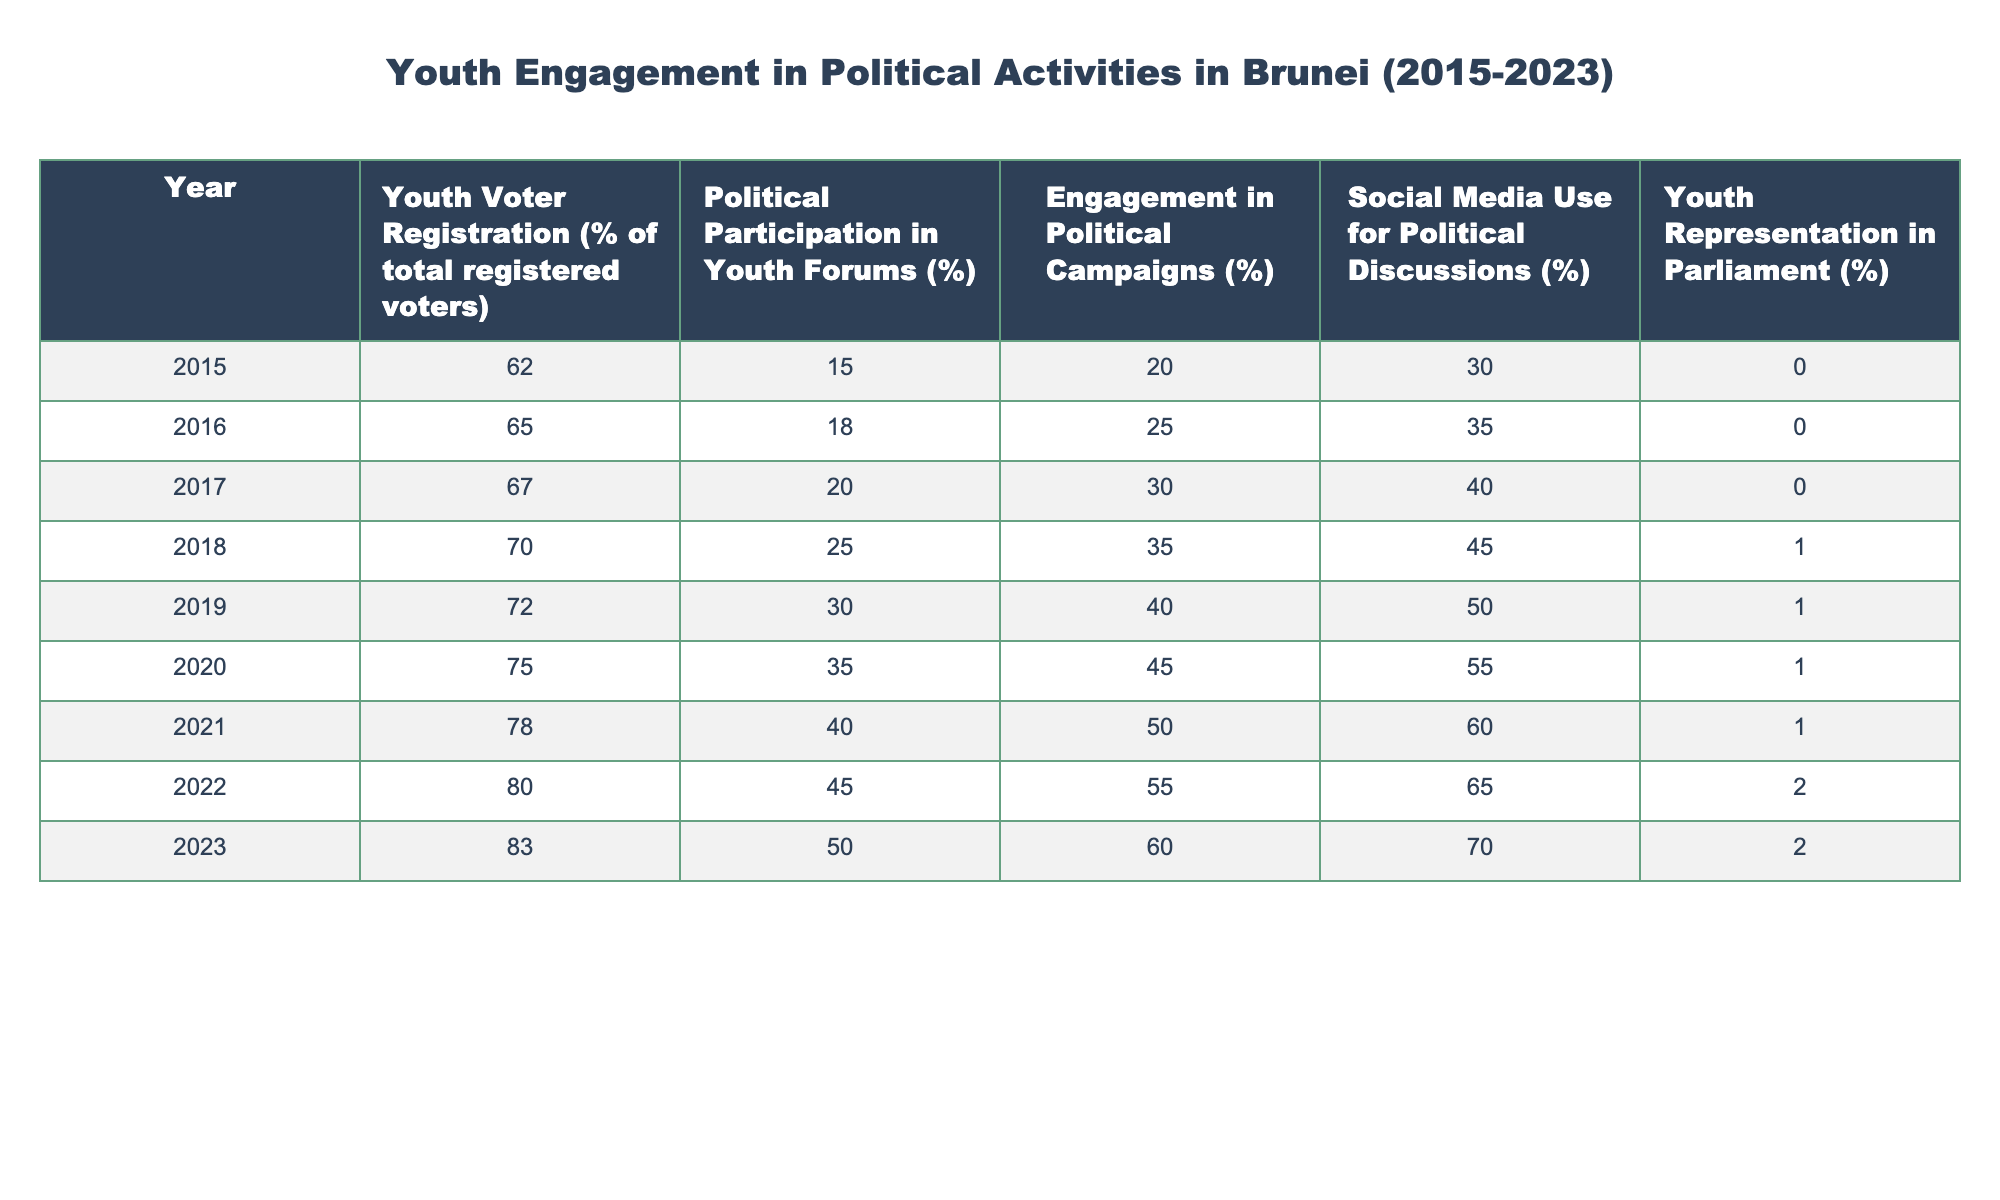What was the youth voter registration percentage in 2021? The table shows that in 2021, the youth voter registration percentage was listed as 78%.
Answer: 78% What is the highest percentage of youth engagement in political campaigns recorded within the years? By comparing the "Engagement in Political Campaigns (%)" column, 60% in 2023 is the highest recorded percentage throughout the years.
Answer: 60% Is there any year where youth representation in Parliament was above 2%? Looking at the "Youth Representation in Parliament (%)" column, the maximum value is 2% in both 2022 and 2023, indicating there were no years above this value.
Answer: No What is the average percentage of political participation in youth forums from 2015 to 2023? To calculate the average, sum the percentages from 2015 (15) to 2023 (50) which equals 15 + 18 + 20 + 25 + 30 + 35 + 40 + 45 + 50 =  268. Since there are 9 years, dividing gives an average of 268/9 = approximately 29.78%.
Answer: 29.78% How much did the use of social media for political discussions increase from 2015 to 2023? The social media use for political discussions rose from 30% in 2015 to 70% in 2023. The increase is calculated as 70 - 30 = 40%.
Answer: 40% In which year did the percentage of youth voter registration exceed 75%? From the "Youth Voter Registration (%)" column, it shows that the percentage first surpassed 75% in 2020.
Answer: 2020 Was there any increase in youth representation in Parliament between 2022 and 2023? Comparing the "Youth Representation in Parliament (%)" values, they were 2% in both 2022 and 2023, indicating no increase during that period.
Answer: No What year had the lowest percentage of youth participation in political forums? The table indicates that the lowest participation was in 2015 at 15%.
Answer: 2015 